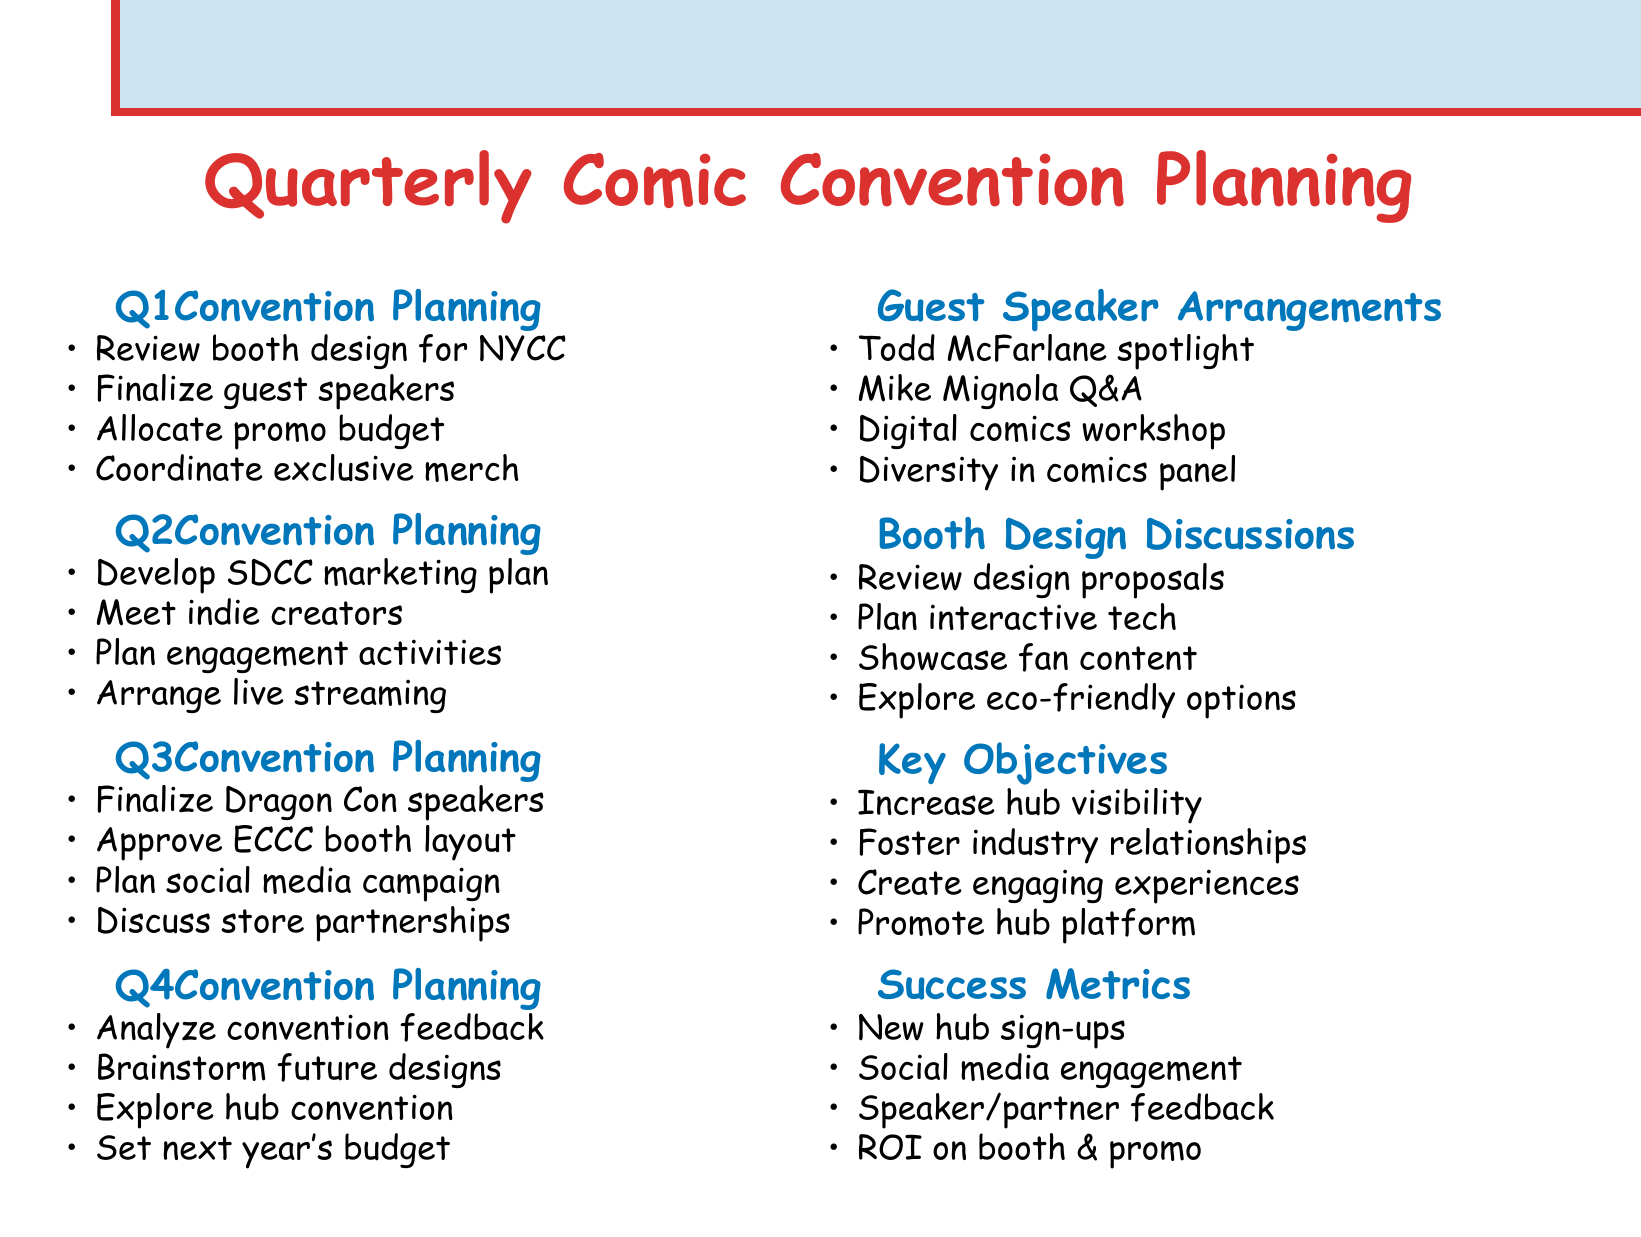What is the first item in Q1 Convention Planning? The first item listed under Q1 Convention Planning is "Review and finalize booth design for New York Comic Con."
Answer: Review and finalize booth design for New York Comic Con Who is the guest speaker for the diversity in comics panel? The document mentions Marjorie Liu and G. Willow Wilson as participants in the diversity in comics panel.
Answer: Marjorie Liu and G. Willow Wilson What type of session is planned with Mike Mignola? The document specifies a Q&A session with Mike Mignola.
Answer: Q&A session How many convention planning sections are there in the agenda? The agenda includes four convention planning sections, one for each quarter.
Answer: Four Which quarter discusses the marketing plan for San Diego Comic-Con International? The Q2 Convention Strategy is the section that discusses the marketing plan for San Diego Comic-Con International.
Answer: Q2 What is one of the key objectives mentioned? The key objectives highlight "Increase community hub visibility at major comic conventions."
Answer: Increase community hub visibility How will success be measured in terms of ROI? Success metrics include "Return on investment for booth design and promotional materials."
Answer: Return on investment for booth design and promotional materials What is one innovative idea brainstormed for future conventions? The document suggests exploring opportunities for hosting a dedicated community hub convention.
Answer: Hosting a dedicated community hub convention Which comic book publisher are we coordinating with for exclusive merchandise? The document mentions coordinating with Marvel and DC Comics for exclusive merchandise.
Answer: Marvel and DC Comics 